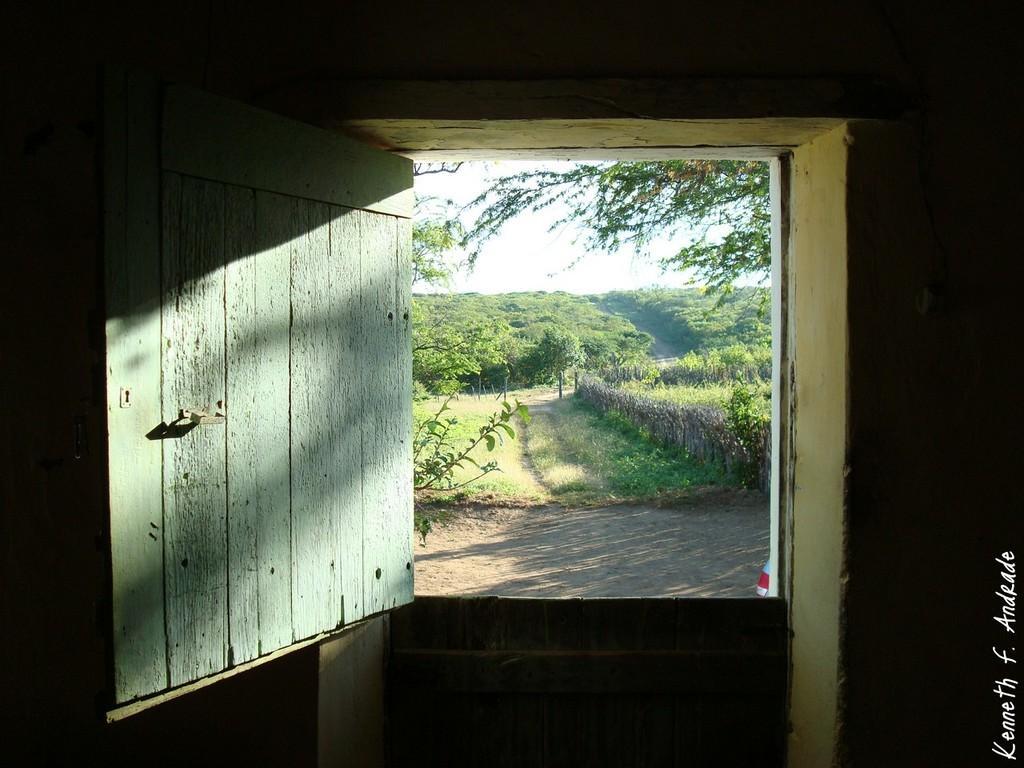Can you describe this image briefly? In this image there are doors, wall, plants, grass, trees,sky and a watermark on the image. 